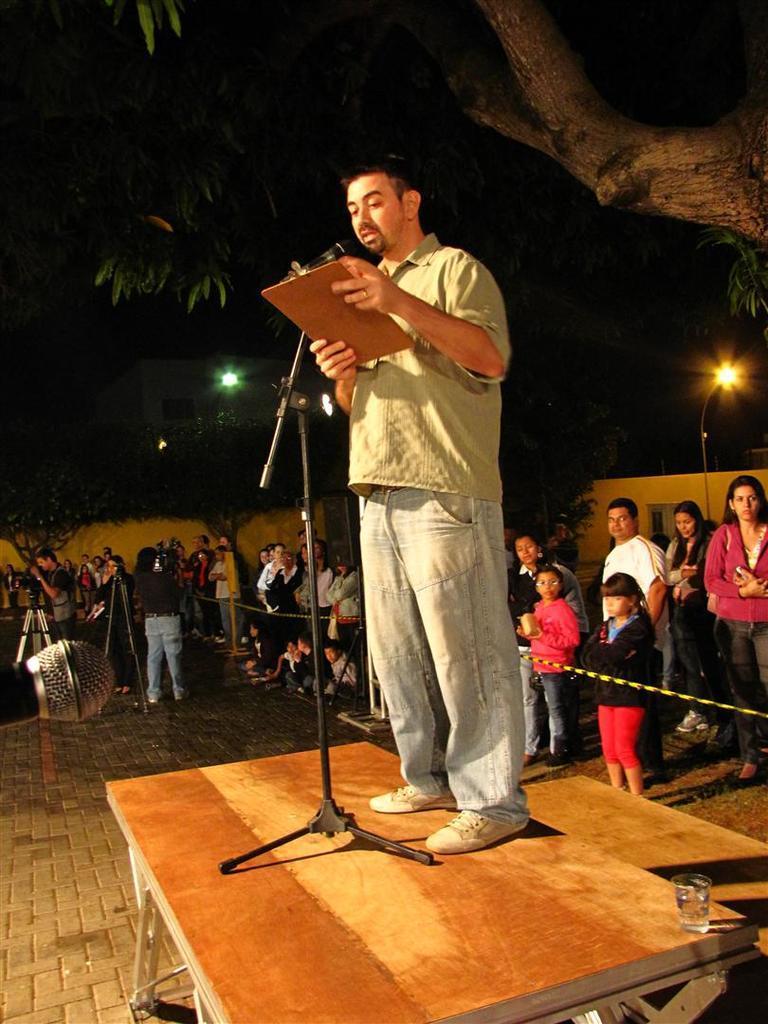Describe this image in one or two sentences. In the picture we can see a person wearing green color shirt standing on stage holding pad in his hands and there is microphone and we can see some group of people standing behind rope and in the background there are some trees, lights and there is a wall. 